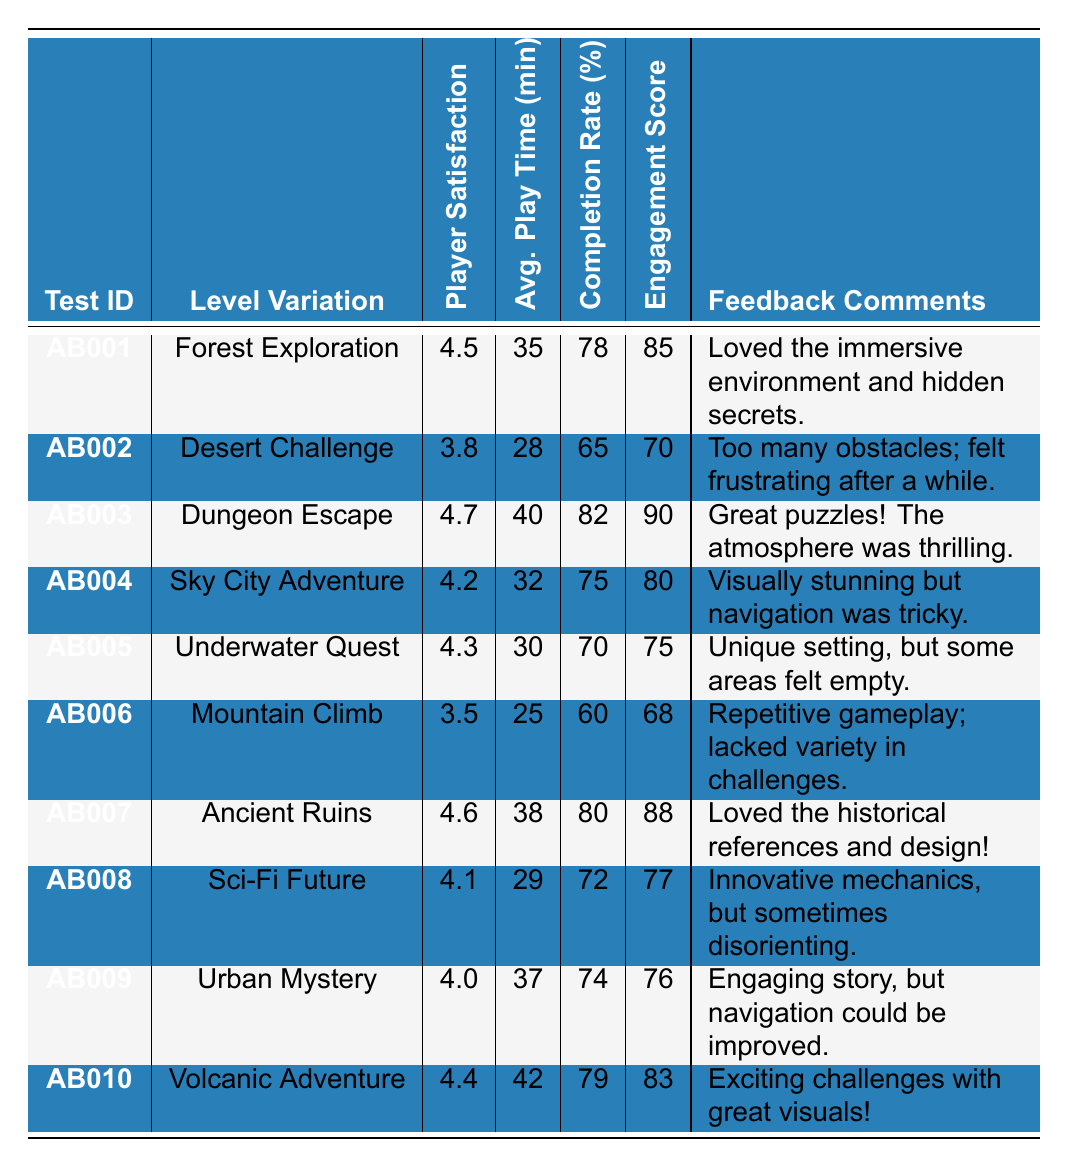What was the player satisfaction rating for the "Dungeon Escape" level variation? The table shows that the player satisfaction rating for "Dungeon Escape" (Test ID: AB003) is 4.7.
Answer: 4.7 Which level variation had the highest completion rate? By comparing the completion rates, "Dungeon Escape" has the highest completion rate at 82%.
Answer: Dungeon Escape What is the average play time for the "Forest Exploration" and "Underwater Quest"? The average play time for "Forest Exploration" is 35 minutes and for "Underwater Quest" is 30 minutes. Adding these gives 35 + 30 = 65 minutes. Dividing by 2 gives an average of 65/2 = 32.5 minutes.
Answer: 32.5 minutes Did "Mountain Climb" receive a player satisfaction rating higher than 3.5? The player satisfaction rating for "Mountain Climb" is 3.5, which is not higher than 3.5.
Answer: No Which level variations have an engagement score above 80? The engagement scores above 80 are for "Dungeon Escape" (90), "Ancient Ruins" (88), and "Volcanic Adventure" (83).
Answer: Dungeon Escape, Ancient Ruins, and Volcanic Adventure Calculate the median player satisfaction rating of all level variations. The player satisfaction ratings are: 4.5, 3.8, 4.7, 4.2, 4.3, 3.5, 4.6, 4.1, 4.0, and 4.4. Arranging these in order gives: 3.5, 3.8, 4.0, 4.1, 4.2, 4.3, 4.4, 4.5, 4.6, 4.7. Since there are 10 data points, the median is the average of the 5th and 6th values: (4.2 + 4.3) / 2 = 4.25.
Answer: 4.25 Which level had the lowest average play time? The average play time for "Mountain Climb" is 25 minutes, which is the lowest compared to the other levels.
Answer: Mountain Climb Did any level variation have a player satisfaction rating below 4.0? Yes, "Desert Challenge" has a player satisfaction rating of 3.8 and "Mountain Climb" has a rating of 3.5, both below 4.0.
Answer: Yes What is the total engagement score for "Desert Challenge" and "Mountain Climb"? The engagement scores are 70 for "Desert Challenge" and 68 for "Mountain Climb". Adding these gives 70 + 68 = 138.
Answer: 138 Which level variation received the feedback comment mentioning "immersive environment"? The feedback mentioning "immersive environment" is provided for "Forest Exploration".
Answer: Forest Exploration 